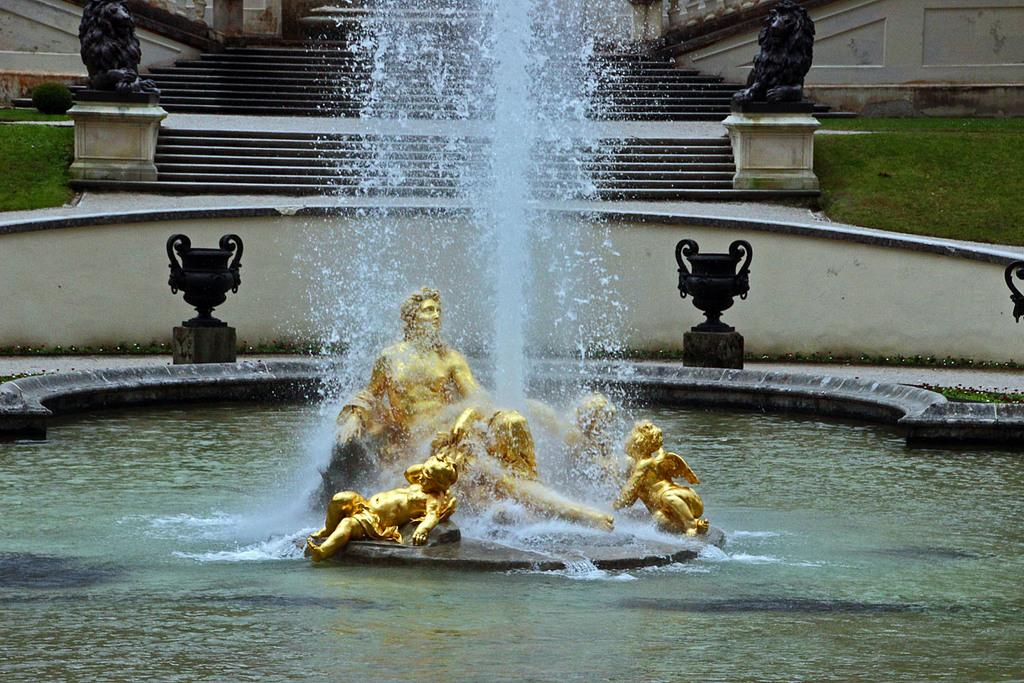What is the main feature in the image? There is a water fountain in the image. What is located near the water fountain? The water fountain has statues around it. What can be seen illuminating the area in the image? There are lights visible in the image. What architectural feature is present in the image? There is a staircase in the image. What type of rhythm can be heard coming from the chickens in the image? There are no chickens present in the image, so it's not possible to determine what rhythm might be heard. 